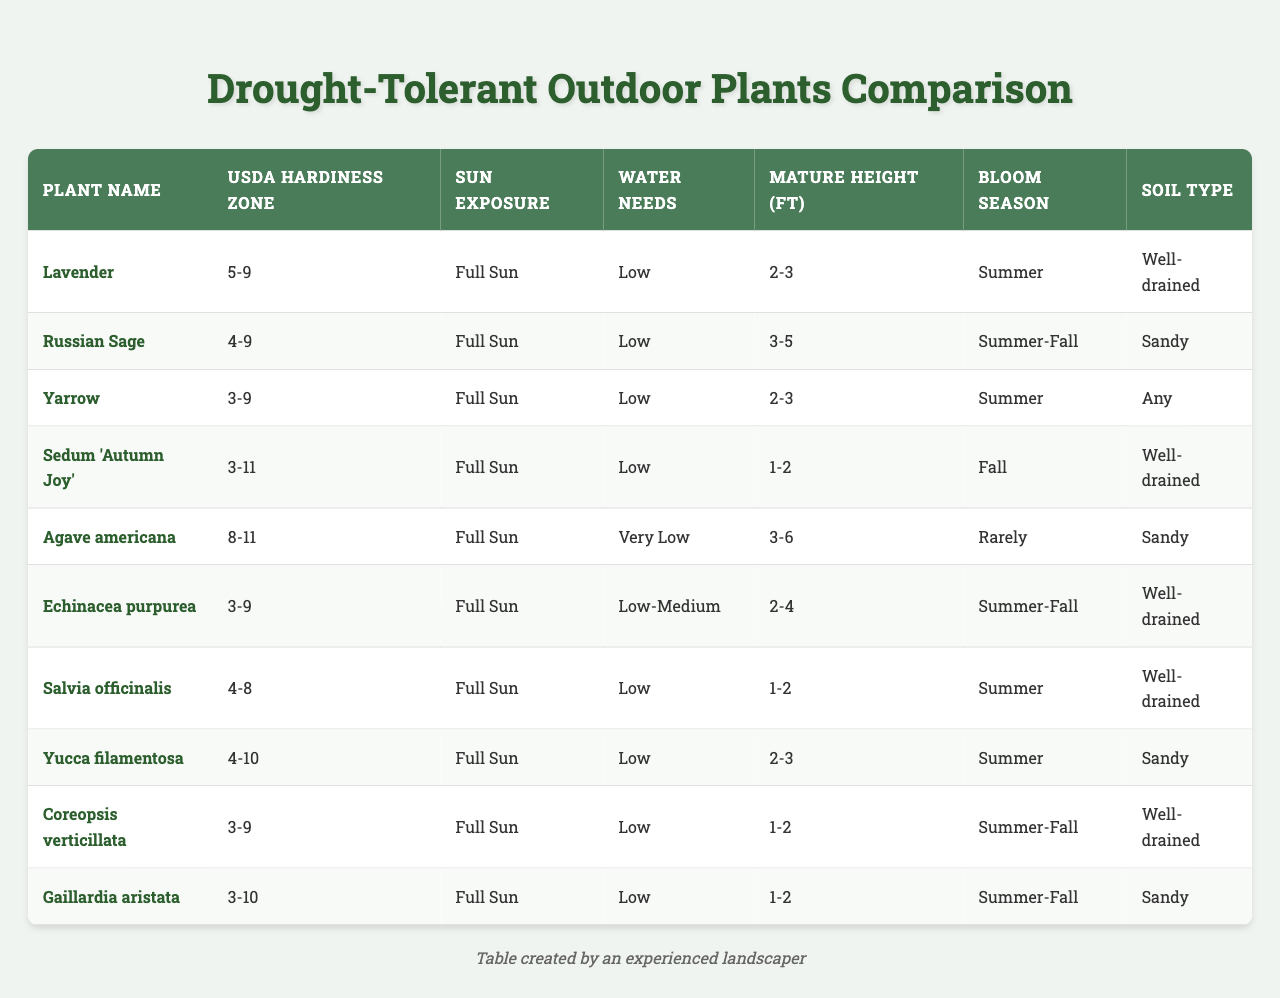What is the sun exposure requirement for Yarrow? The table lists Yarrow under "Sun Exposure" as "Full Sun."
Answer: Full Sun Which plant has the lowest water needs? The table indicates that "Agave americana" has "Very Low" water needs, which is less than all the others listed.
Answer: Agave americana What is the mature height range of 'Sedum Autumn Joy'? The table specifies that 'Sedum Autumn Joy' has a mature height of "1-2" feet.
Answer: 1-2 feet How many plants have a mature height of 2-3 feet? The plants with a mature height of 2-3 feet are Lavender, Yarrow, Echinacea purpurea, and Yucca filamentosa. This gives a total of four plants.
Answer: 4 Is it true that all plants listed require full sun? By checking the "Sun Exposure" column, all plants are noted as requiring "Full Sun," confirming the statement is true.
Answer: True Which plant blooms in the fall and has low water needs? From the table, "Sedum 'Autumn Joy'" blooms in the fall and also has low water needs.
Answer: Sedum 'Autumn Joy' What is the average mature height of the plants listed that bloom in summer? The plants blooming in summer are Lavender (2.5 average), Yarrow (2.5 average), Echinacea purpurea (3 average), Salvia officinalis (1.5 average), and Yucca filamentosa (2.5 average). This results in an average mature height of (2.5 + 2.5 + 3 + 1.5 + 2.5) / 5 = 2.4 feet.
Answer: 2.4 feet How many of the listed plants thrive in USDA Hardiness Zones 3-5? The plants thriving in USDA Hardiness Zones 3-5 are Yarrow, Echinacea purpurea, Coreopsis verticillata, and Gaillardia aristata, making a total of four plants.
Answer: 4 Are there any plants that can grow in soil types other than well-drained or sandy? By analyzing the "Soil Type" column, Yarrow is noted as being able to grow in "Any" soil type. This indicates that there is at least one plant with a different soil requirement.
Answer: Yes Which plant species has the broadest USDA Hardiness Zone range? "Sedum 'Autumn Joy'" has a hardiness zone range of "3-11," which is the broadest among the listed plants.
Answer: Sedum 'Autumn Joy' 